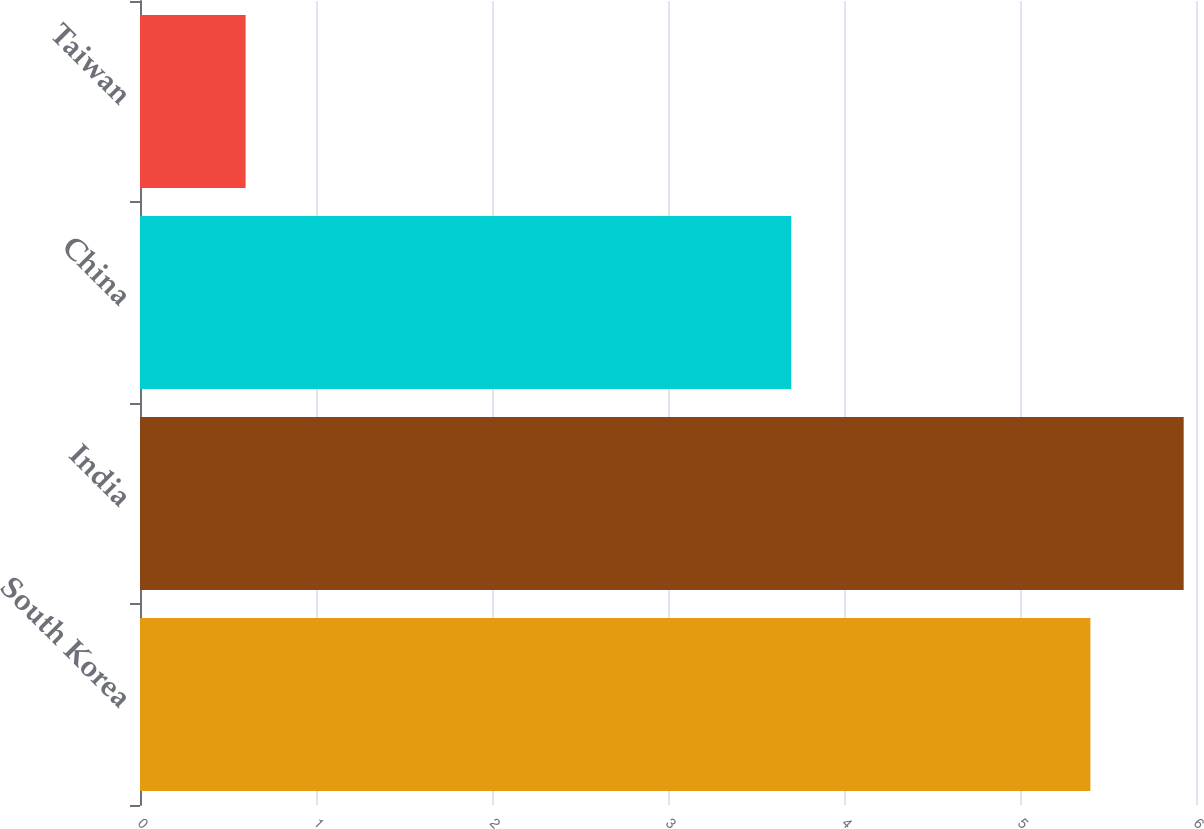Convert chart to OTSL. <chart><loc_0><loc_0><loc_500><loc_500><bar_chart><fcel>South Korea<fcel>India<fcel>China<fcel>Taiwan<nl><fcel>5.4<fcel>5.93<fcel>3.7<fcel>0.6<nl></chart> 